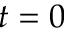Convert formula to latex. <formula><loc_0><loc_0><loc_500><loc_500>t = 0</formula> 